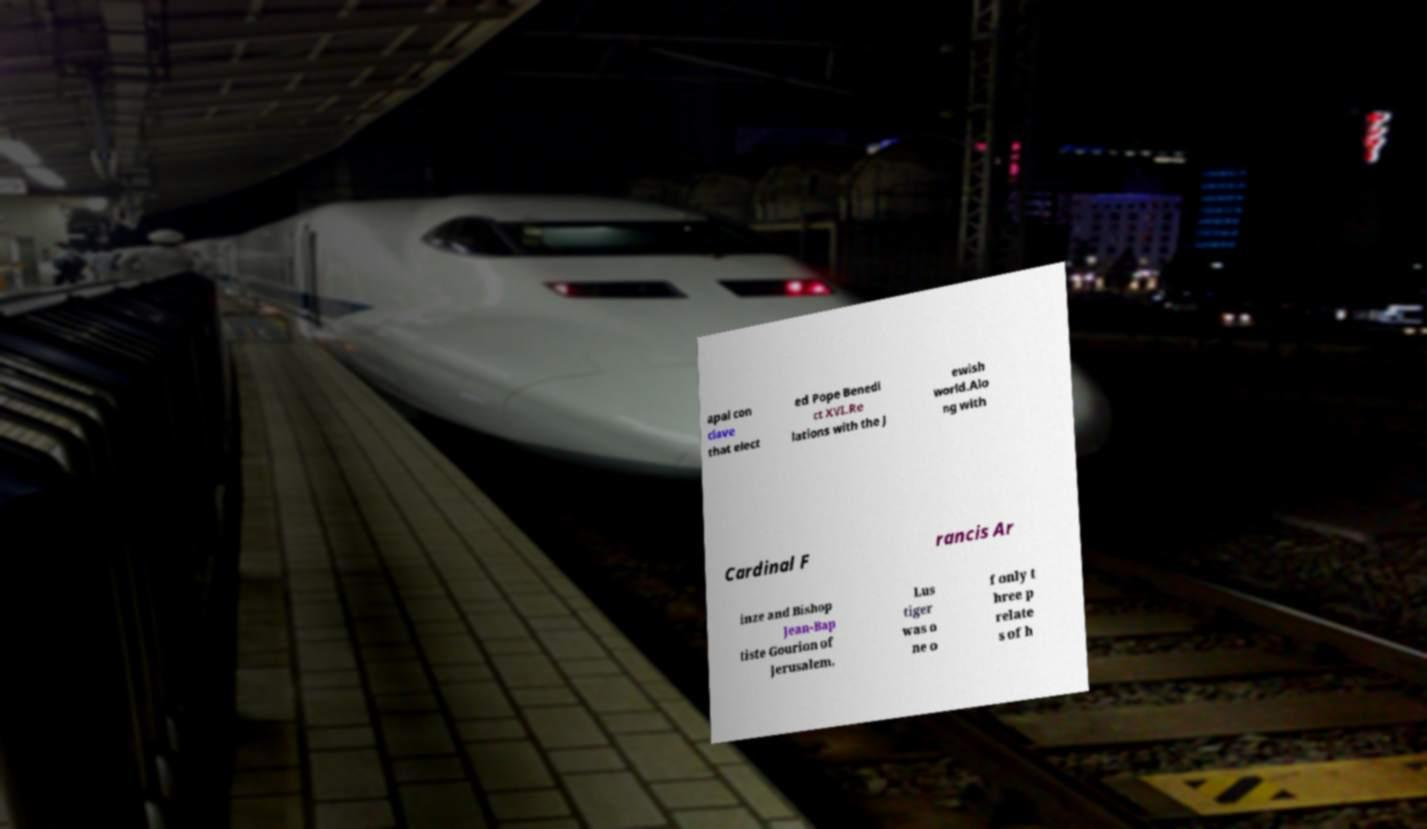Could you extract and type out the text from this image? apal con clave that elect ed Pope Benedi ct XVI.Re lations with the J ewish world.Alo ng with Cardinal F rancis Ar inze and Bishop Jean-Bap tiste Gourion of Jerusalem, Lus tiger was o ne o f only t hree p relate s of h 